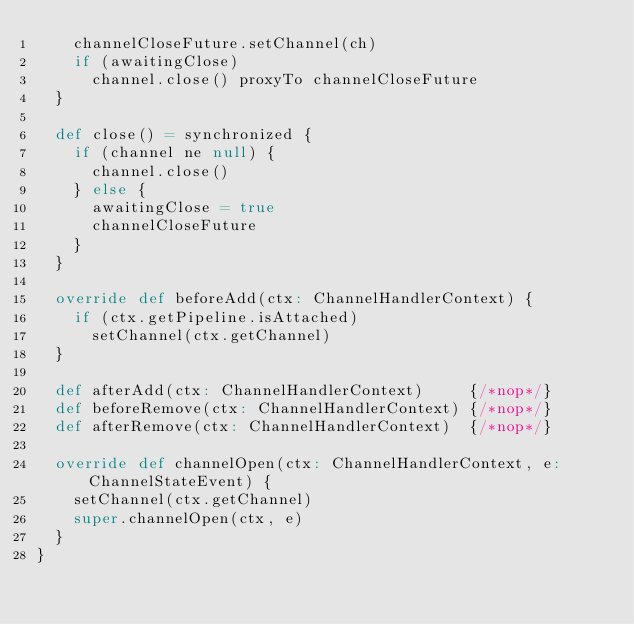Convert code to text. <code><loc_0><loc_0><loc_500><loc_500><_Scala_>    channelCloseFuture.setChannel(ch)
    if (awaitingClose)
      channel.close() proxyTo channelCloseFuture
  }

  def close() = synchronized {
    if (channel ne null) {
      channel.close()
    } else {
      awaitingClose = true
      channelCloseFuture
    }
  }

  override def beforeAdd(ctx: ChannelHandlerContext) {
    if (ctx.getPipeline.isAttached)
      setChannel(ctx.getChannel)
  }

  def afterAdd(ctx: ChannelHandlerContext)     {/*nop*/}
  def beforeRemove(ctx: ChannelHandlerContext) {/*nop*/}
  def afterRemove(ctx: ChannelHandlerContext)  {/*nop*/}

  override def channelOpen(ctx: ChannelHandlerContext, e: ChannelStateEvent) {
    setChannel(ctx.getChannel)
    super.channelOpen(ctx, e)
  }
}
</code> 